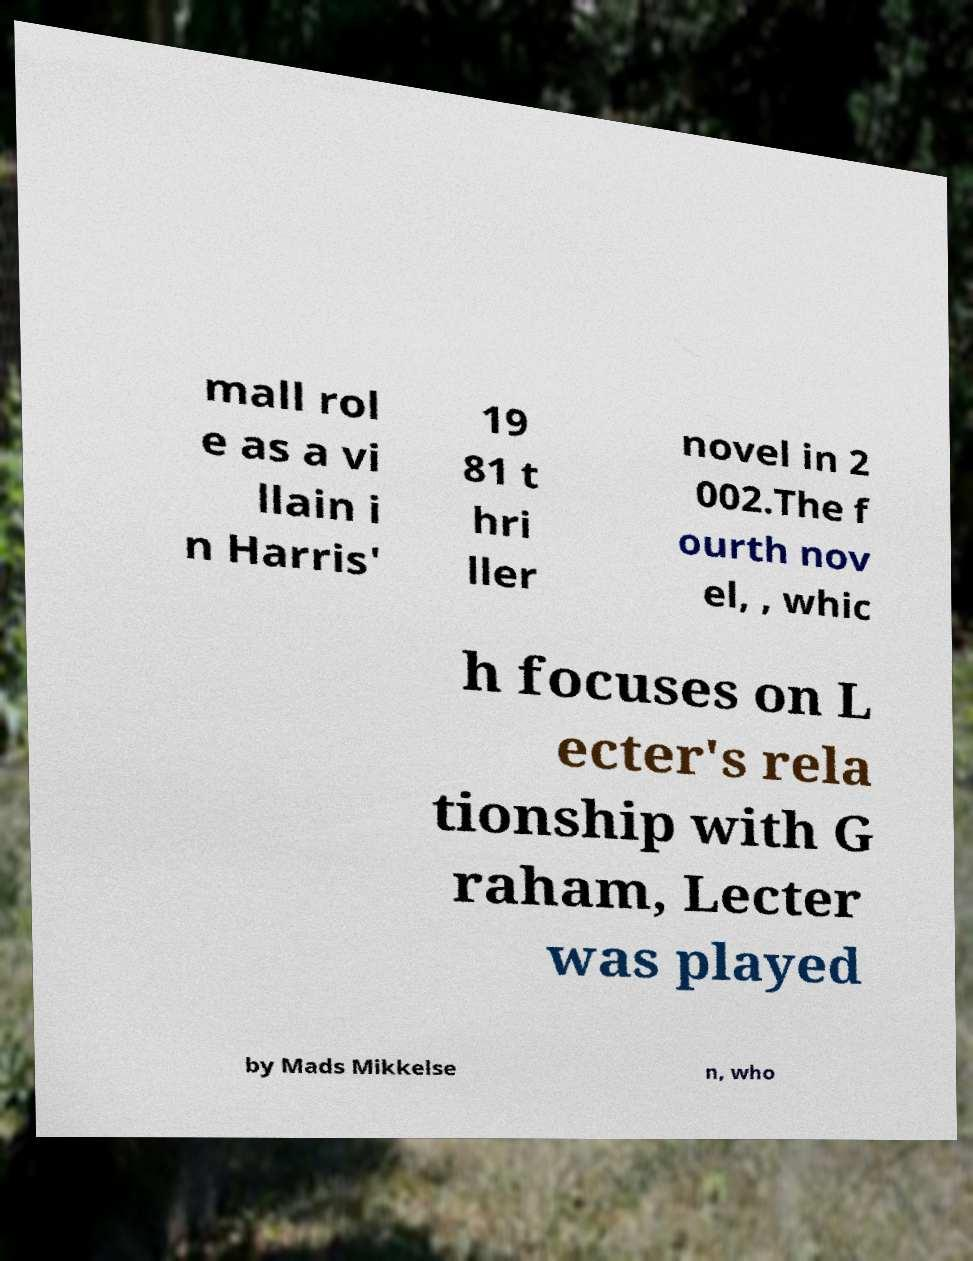Please read and relay the text visible in this image. What does it say? mall rol e as a vi llain i n Harris' 19 81 t hri ller novel in 2 002.The f ourth nov el, , whic h focuses on L ecter's rela tionship with G raham, Lecter was played by Mads Mikkelse n, who 